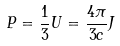Convert formula to latex. <formula><loc_0><loc_0><loc_500><loc_500>P = \frac { 1 } { 3 } U = \frac { 4 \pi } { 3 c } J</formula> 